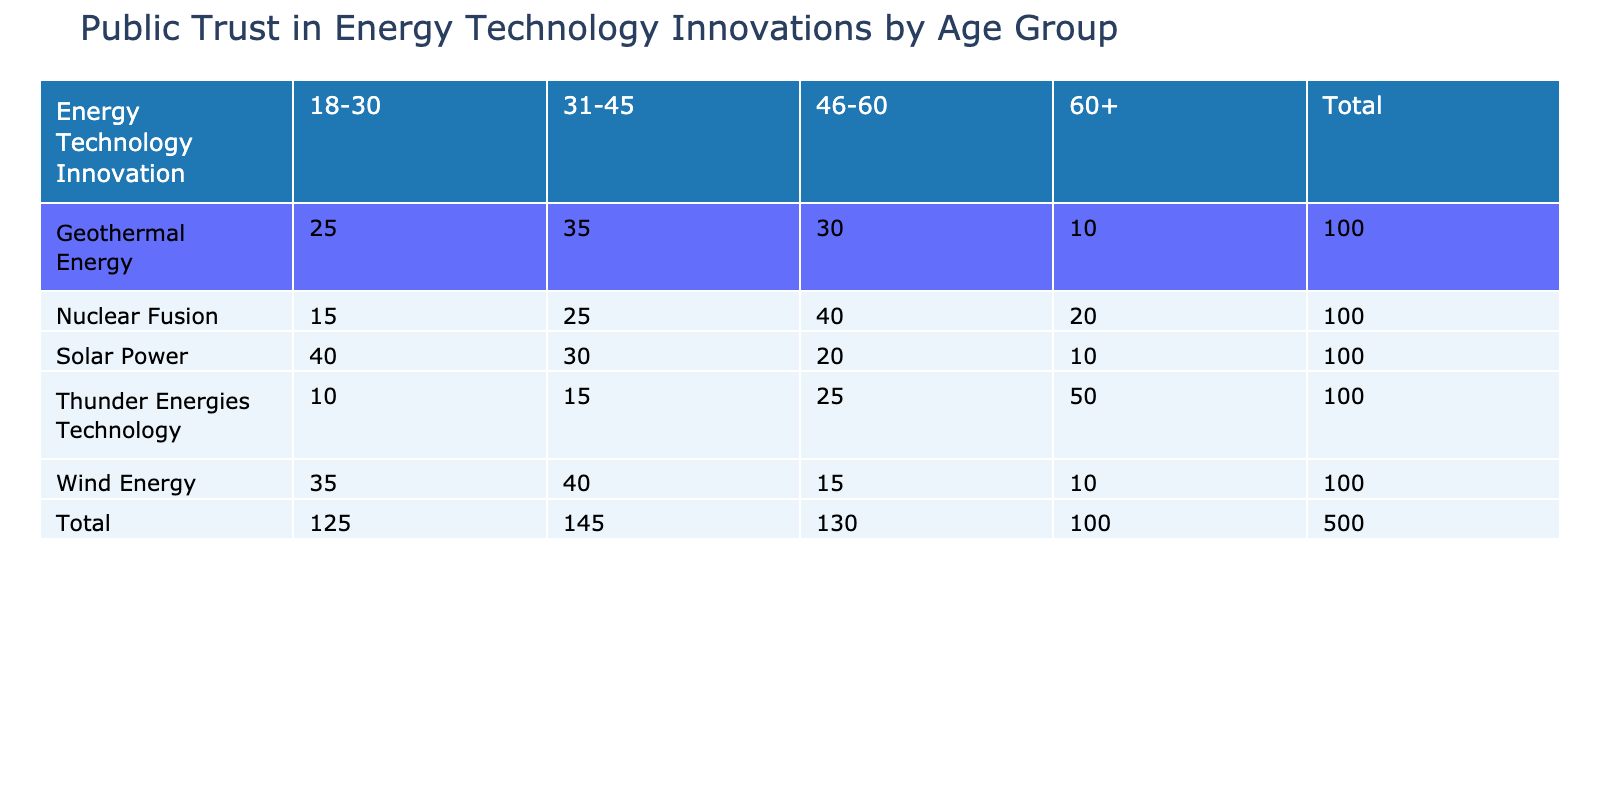What is the level of trust in Solar Power among the 60+ age group? The table shows that for the Solar Power category, the level of trust for the 60+ age group is recorded as 10.
Answer: 10 Which energy technology has the highest average level of trust across all age groups? To find the average level of trust for each technology, sum the levels for each age group and divide by the number of groups. - Solar Power: (40 + 30 + 20 + 10)/4 = 25 - Wind Energy: (35 + 40 + 15 + 10)/4 = 25 - Geothermal Energy: (25 + 35 + 30 + 10)/4 = 25 - Nuclear Fusion: (15 + 25 + 40 + 20)/4 = 25 - Thunder Energies Technology: (10 + 15 + 25 + 50)/4 = 25. All have the same average trust level of 25.
Answer: All have the same average trust level of 25 Is the level of trust in Nuclear Fusion higher than in Thunder Energies Technology for the 31-45 age group? For the 31-45 age group, the trust level in Nuclear Fusion is 25, whereas the level for Thunder Energies Technology is 15. Comparing these values, Nuclear Fusion has a higher trust level.
Answer: Yes What is the total level of trust in Geothermal Energy across all age groups combined? Summing the levels of trust across all age groups for Geothermal Energy gives: 25 + 35 + 30 + 10 = 100.
Answer: 100 How does the level of trust in Wind Energy for the 46-60 age group compare to that of Solar Power in the same age group? For Wind Energy, the level of trust is 15, while for Solar Power, it is 20. Comparing these, trust in Solar Power is higher than in Wind Energy for the 46-60 age group.
Answer: Solar Power is higher What percentage of respondents aged 60+ trust Thunder Energies Technology at a very low level? There are 50 respondents aged 60+ with a very low trust level in Thunder Energies Technology. The total trust levels in this age group are 10 (Solar) + 10 (Wind) + 10 (Geothermal) + 20 (Nuclear) + 50 (Thunder) = 100. Therefore, the percentage is (50/100) * 100 = 50%.
Answer: 50% 